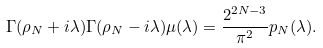<formula> <loc_0><loc_0><loc_500><loc_500>\Gamma ( \rho _ { N } + i \lambda ) \Gamma ( \rho _ { N } - i \lambda ) \mu ( \lambda ) = \frac { 2 ^ { 2 N - 3 } } { \pi ^ { 2 } } p _ { N } ( \lambda ) .</formula> 